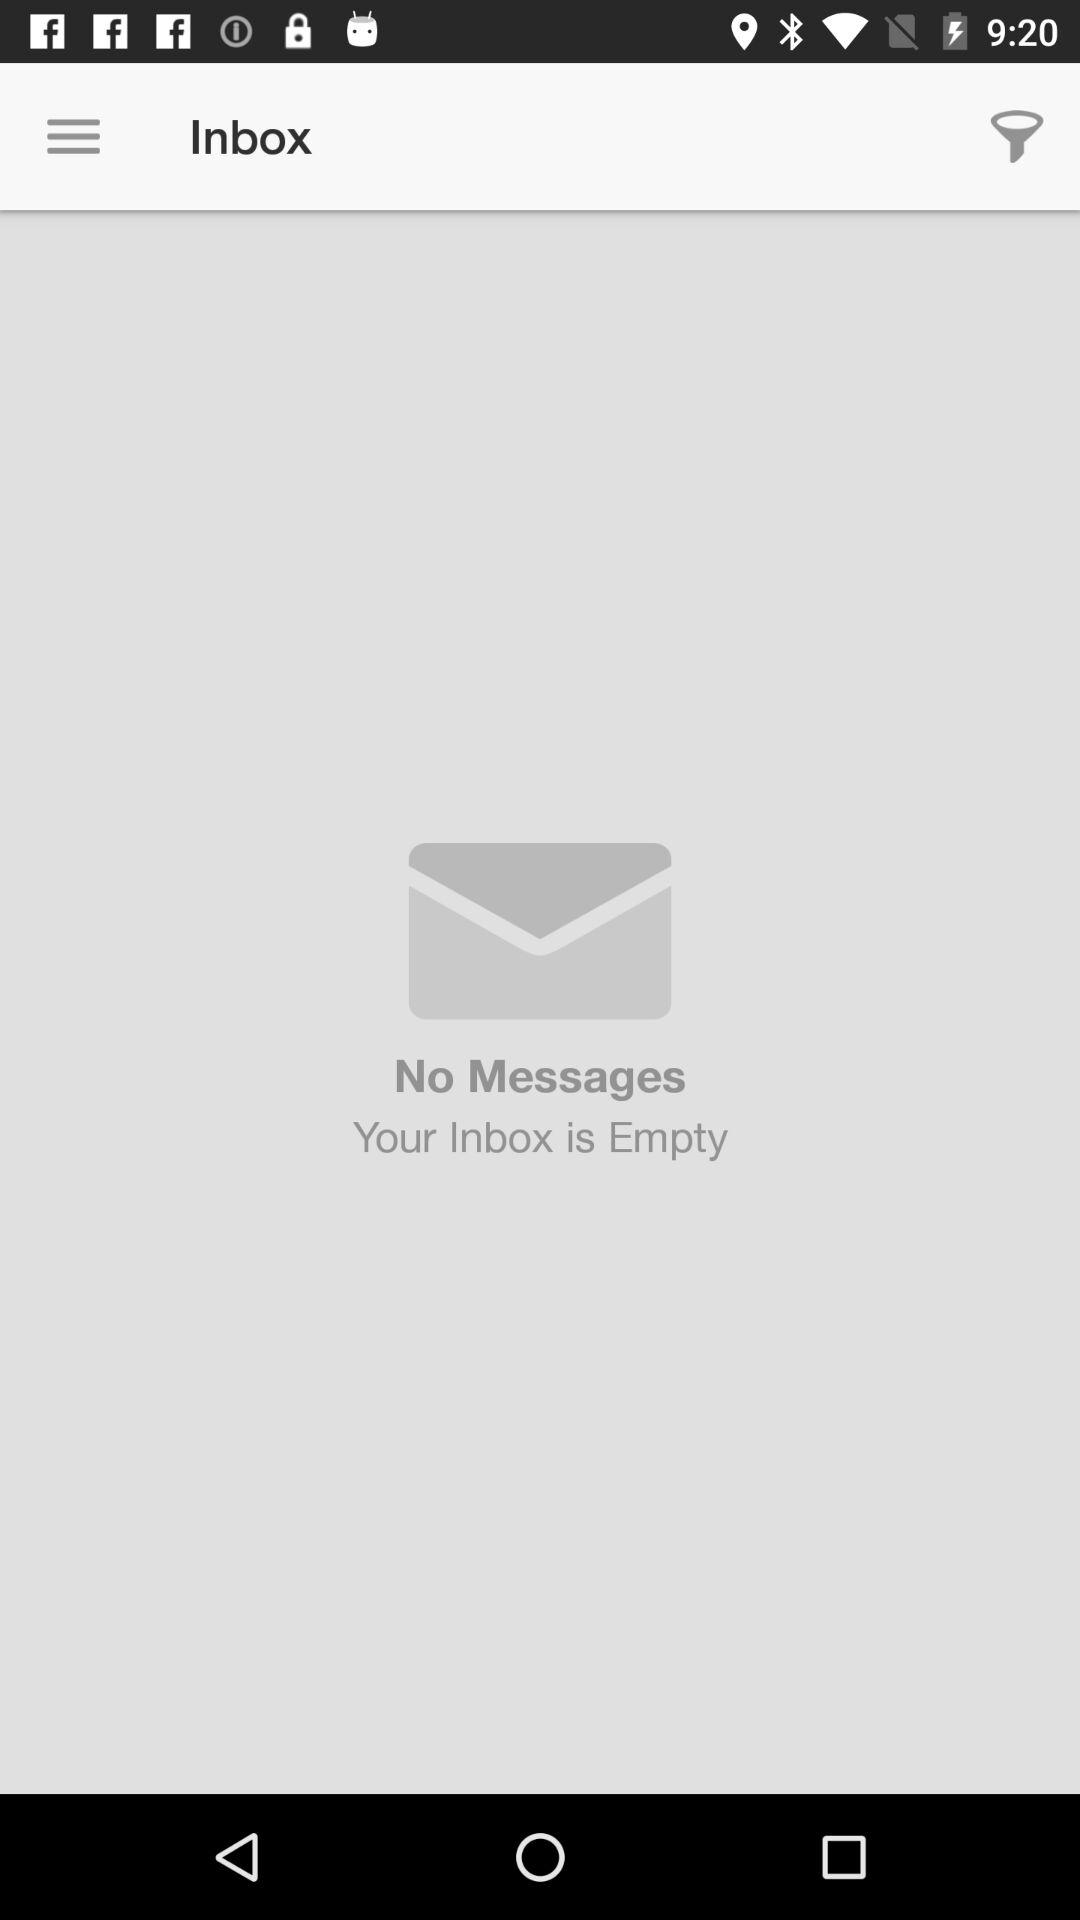How many messages do I have?
Answer the question using a single word or phrase. 0 